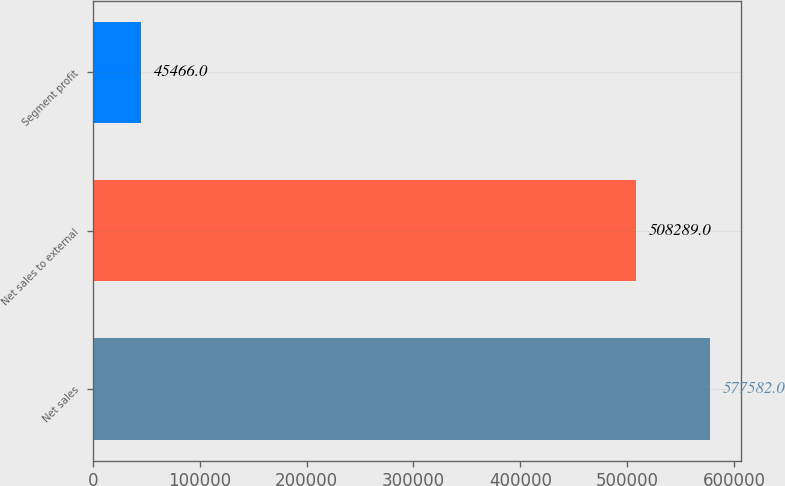<chart> <loc_0><loc_0><loc_500><loc_500><bar_chart><fcel>Net sales<fcel>Net sales to external<fcel>Segment profit<nl><fcel>577582<fcel>508289<fcel>45466<nl></chart> 